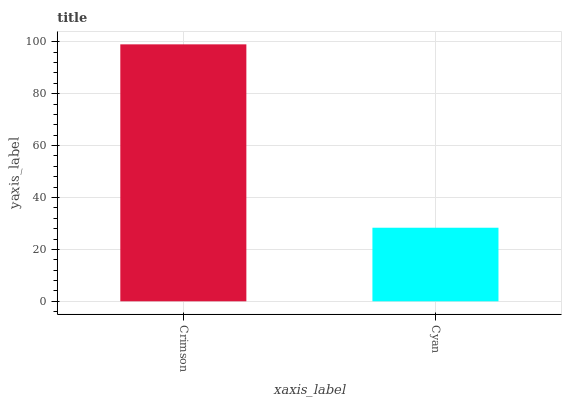Is Cyan the minimum?
Answer yes or no. Yes. Is Crimson the maximum?
Answer yes or no. Yes. Is Cyan the maximum?
Answer yes or no. No. Is Crimson greater than Cyan?
Answer yes or no. Yes. Is Cyan less than Crimson?
Answer yes or no. Yes. Is Cyan greater than Crimson?
Answer yes or no. No. Is Crimson less than Cyan?
Answer yes or no. No. Is Crimson the high median?
Answer yes or no. Yes. Is Cyan the low median?
Answer yes or no. Yes. Is Cyan the high median?
Answer yes or no. No. Is Crimson the low median?
Answer yes or no. No. 